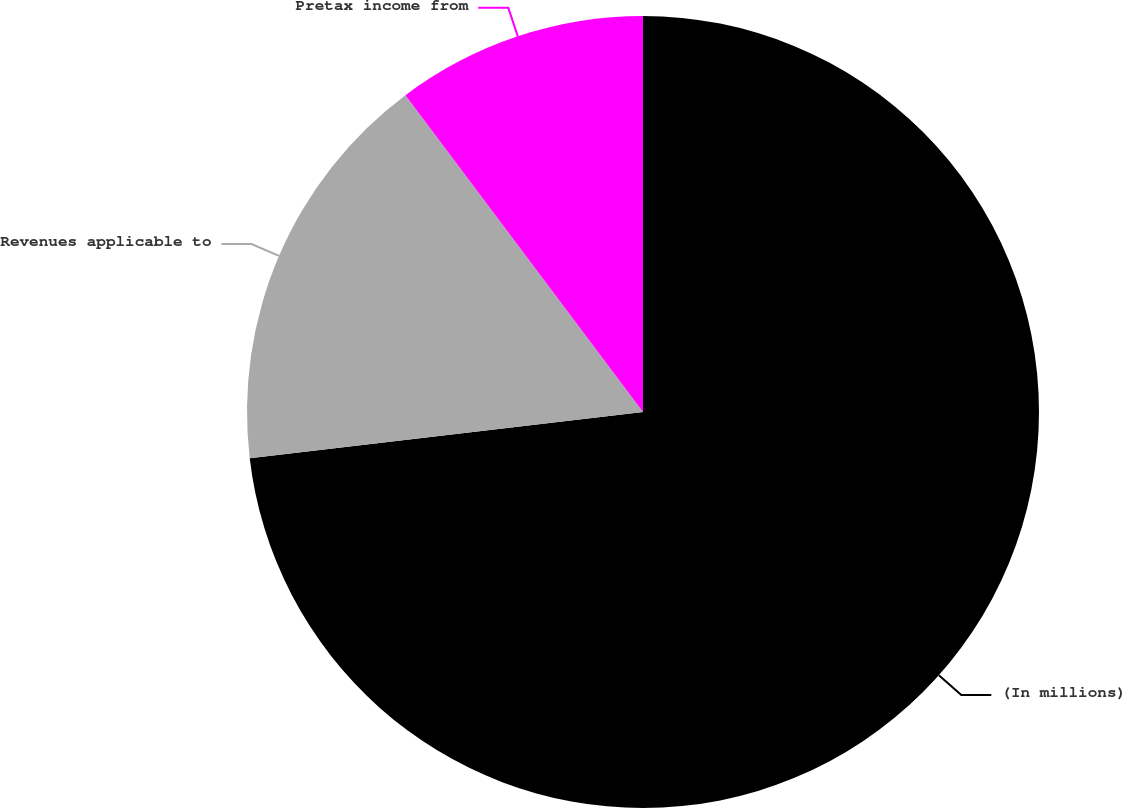Convert chart. <chart><loc_0><loc_0><loc_500><loc_500><pie_chart><fcel>(In millions)<fcel>Revenues applicable to<fcel>Pretax income from<nl><fcel>73.14%<fcel>16.62%<fcel>10.24%<nl></chart> 